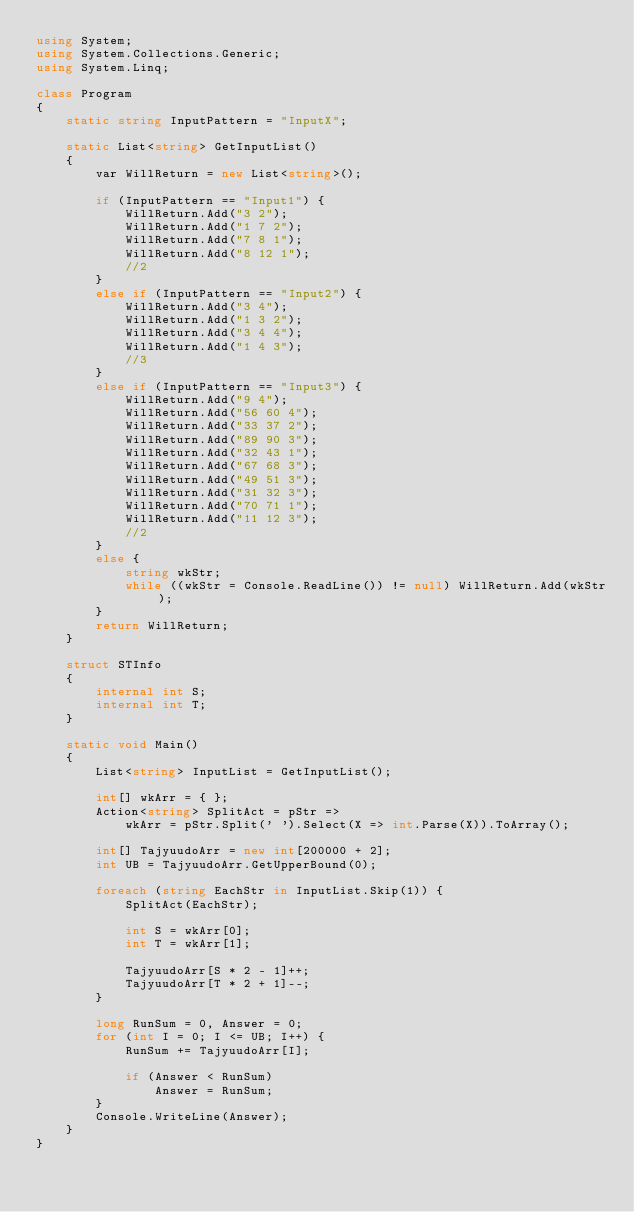<code> <loc_0><loc_0><loc_500><loc_500><_C#_>using System;
using System.Collections.Generic;
using System.Linq;

class Program
{
    static string InputPattern = "InputX";

    static List<string> GetInputList()
    {
        var WillReturn = new List<string>();

        if (InputPattern == "Input1") {
            WillReturn.Add("3 2");
            WillReturn.Add("1 7 2");
            WillReturn.Add("7 8 1");
            WillReturn.Add("8 12 1");
            //2
        }
        else if (InputPattern == "Input2") {
            WillReturn.Add("3 4");
            WillReturn.Add("1 3 2");
            WillReturn.Add("3 4 4");
            WillReturn.Add("1 4 3");
            //3
        }
        else if (InputPattern == "Input3") {
            WillReturn.Add("9 4");
            WillReturn.Add("56 60 4");
            WillReturn.Add("33 37 2");
            WillReturn.Add("89 90 3");
            WillReturn.Add("32 43 1");
            WillReturn.Add("67 68 3");
            WillReturn.Add("49 51 3");
            WillReturn.Add("31 32 3");
            WillReturn.Add("70 71 1");
            WillReturn.Add("11 12 3");
            //2
        }
        else {
            string wkStr;
            while ((wkStr = Console.ReadLine()) != null) WillReturn.Add(wkStr);
        }
        return WillReturn;
    }

    struct STInfo
    {
        internal int S;
        internal int T;
    }

    static void Main()
    {
        List<string> InputList = GetInputList();

        int[] wkArr = { };
        Action<string> SplitAct = pStr =>
            wkArr = pStr.Split(' ').Select(X => int.Parse(X)).ToArray();

        int[] TajyuudoArr = new int[200000 + 2];
        int UB = TajyuudoArr.GetUpperBound(0);

        foreach (string EachStr in InputList.Skip(1)) {
            SplitAct(EachStr);

            int S = wkArr[0];
            int T = wkArr[1];

            TajyuudoArr[S * 2 - 1]++;
            TajyuudoArr[T * 2 + 1]--;
        }

        long RunSum = 0, Answer = 0;
        for (int I = 0; I <= UB; I++) {
            RunSum += TajyuudoArr[I];

            if (Answer < RunSum)
                Answer = RunSum;
        }
        Console.WriteLine(Answer);
    }
}
</code> 